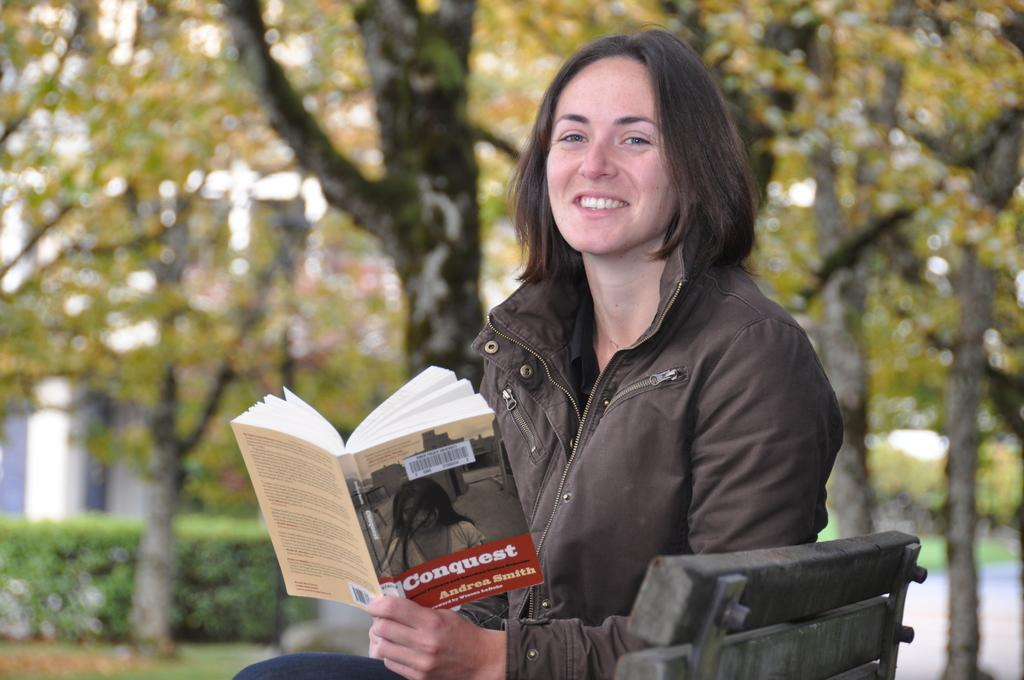<image>
Offer a succinct explanation of the picture presented. a woman reading a book in the park that is titled 'conquest' 